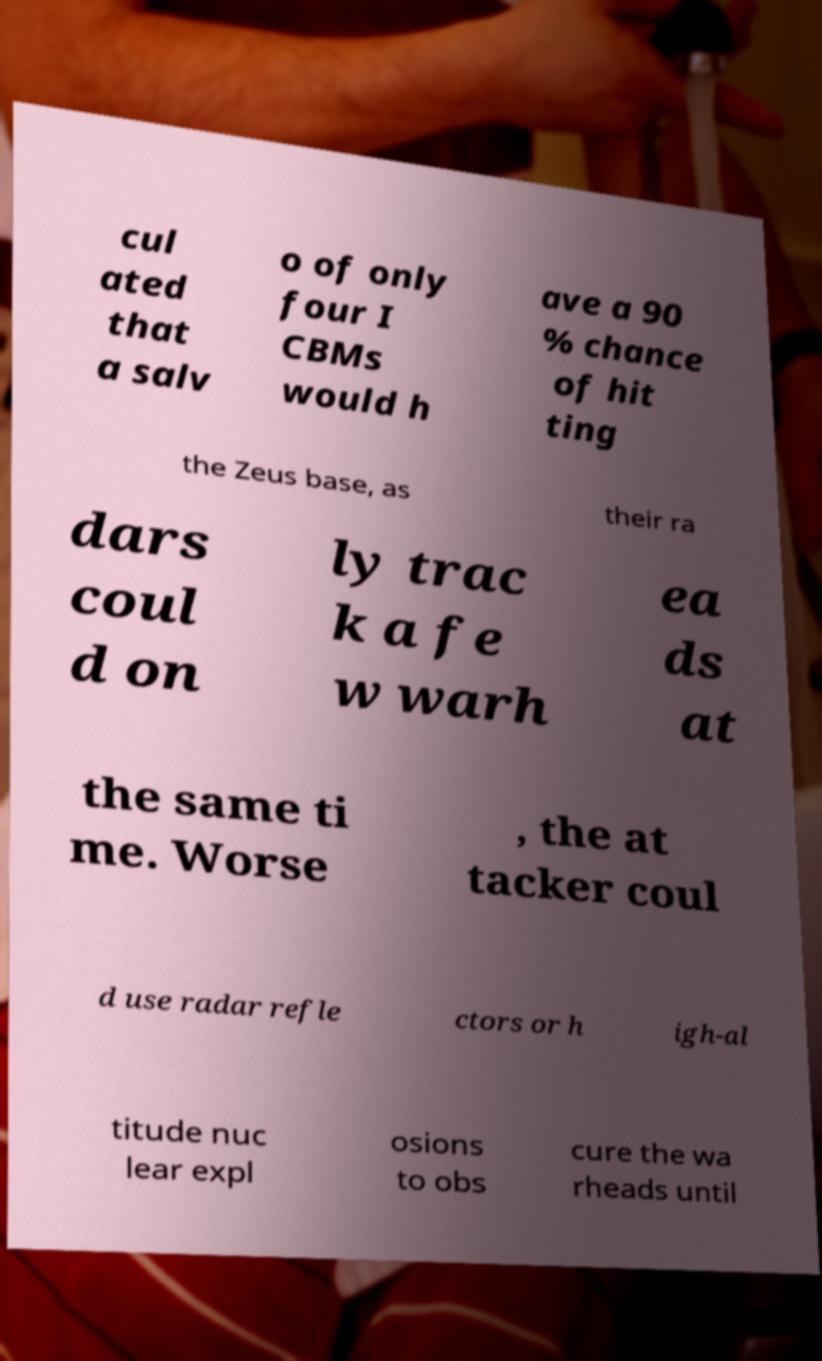What messages or text are displayed in this image? I need them in a readable, typed format. cul ated that a salv o of only four I CBMs would h ave a 90 % chance of hit ting the Zeus base, as their ra dars coul d on ly trac k a fe w warh ea ds at the same ti me. Worse , the at tacker coul d use radar refle ctors or h igh-al titude nuc lear expl osions to obs cure the wa rheads until 